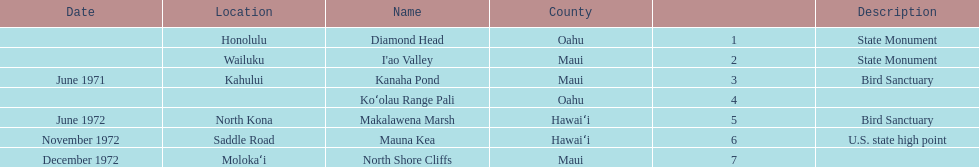Which county is featured the most on the chart? Maui. 